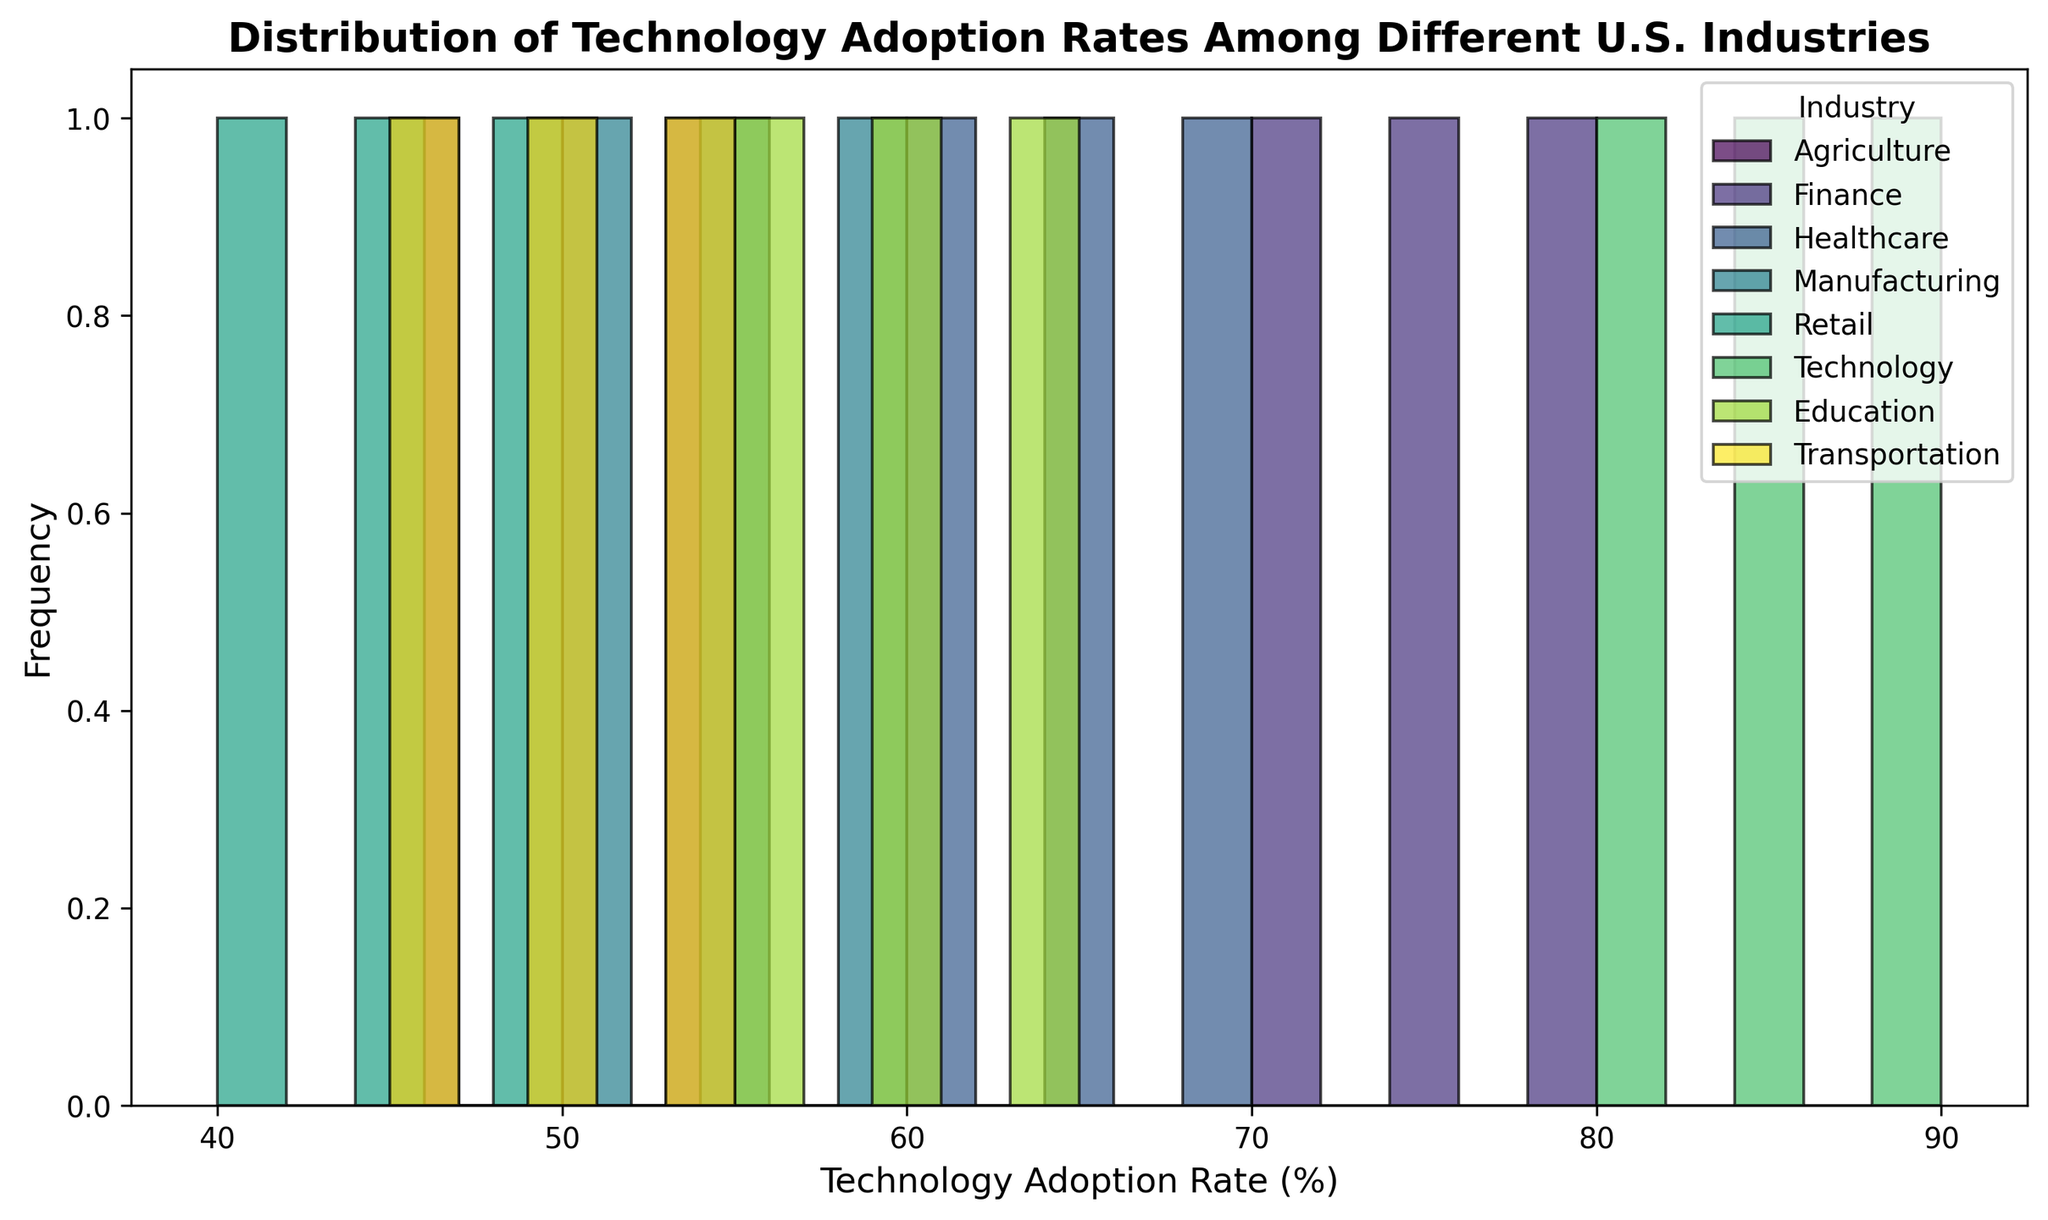What is the most common technology adoption rate for the Technology industry? By observing the histogram section for the Technology industry data, we can see which rate appears most frequently (the highest bar).
Answer: 80% Which industry has the highest technology adoption rate according to the histogram? To determine this, we look for the industry with the highest adoption rate bar among all industries.
Answer: Technology Compare the distributions of technology adoption rates between Agriculture and Finance. Which industry shows higher adoption rates more frequently? By comparing the histograms of the Agriculture and Finance industries, we can see that Finance has more frequent higher adoption rates, as more bars fall in higher ranges.
Answer: Finance Which industry shows the widest range of technology adoption rates? By examining the spread of the bars for each industry in the histogram, we identify which industry covers the widest rate range.
Answer: Technology How do the technology adoption rates in the Retail industry compare to those in the Healthcare industry? Comparing the range and frequency of bars in the histograms for both industries shows that Healthcare has slightly higher adoption rates than Retail.
Answer: Healthcare 